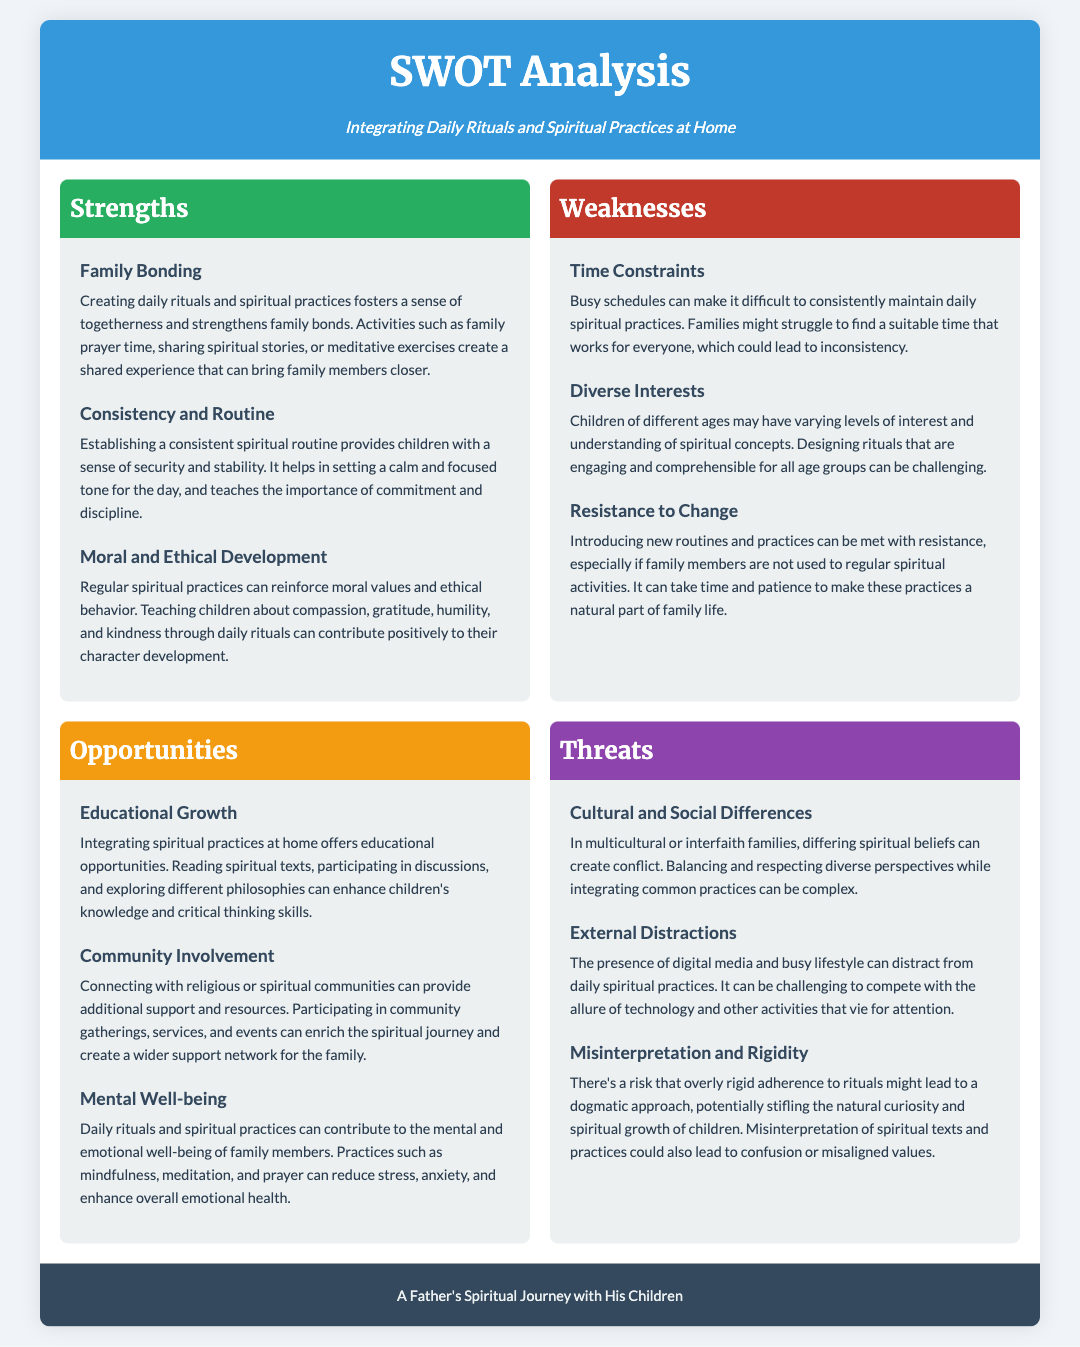What are the strengths of integrating daily rituals? The strengths are listed in the 'Strengths' section of the document, highlighting family bonding, consistency and routine, and moral and ethical development.
Answer: Family Bonding, Consistency and Routine, Moral and Ethical Development What is a key weakness related to time? 'Time Constraints' is mentioned as a key weakness, indicating that busy schedules make it hard to maintain practices consistently.
Answer: Time Constraints Which opportunity can enhance children's knowledge? The opportunity 'Educational Growth' discusses how integrating spiritual practices can provide educational opportunities for children.
Answer: Educational Growth What threat relates to cultural diversity? The threat 'Cultural and Social Differences' refers to potential conflicts arising in multicultural or interfaith families regarding spiritual beliefs.
Answer: Cultural and Social Differences How many strengths are listed in the document? The document provides a total of three strengths under the 'Strengths' section related to integrating rituals and practices.
Answer: 3 What type of mental health benefit is mentioned? The document cites that daily rituals and spiritual practices can contribute to mental well-being, focusing on reducing stress and anxiety.
Answer: Mental Well-being What is a significant external distraction mentioned? 'External Distractions' points out that digital media can compete for attention and distract from daily spiritual practices.
Answer: External Distractions What specific resistance is discussed in the weaknesses? The weakness 'Resistance to Change' highlights that introducing new routines can be challenging if family members are not accustomed to them.
Answer: Resistance to Change 